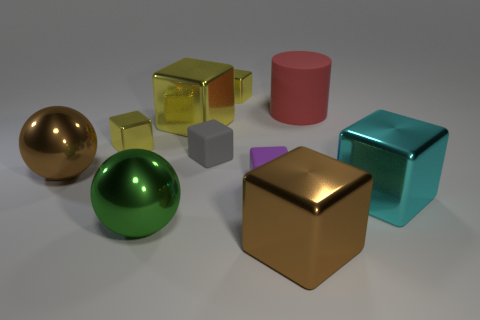How many cylinders are yellow metal things or small yellow objects?
Your response must be concise. 0. Is there any other thing that is the same shape as the large matte object?
Keep it short and to the point. No. Is the number of big green things to the left of the gray block greater than the number of brown cubes that are right of the big cylinder?
Your answer should be compact. Yes. There is a object that is in front of the green shiny thing; how many brown metallic things are behind it?
Provide a short and direct response. 1. How many things are cyan objects or green rubber balls?
Provide a succinct answer. 1. Does the cyan object have the same shape as the large green metal object?
Give a very brief answer. No. What is the material of the green sphere?
Your answer should be compact. Metal. What number of big objects are both in front of the large green thing and on the left side of the tiny purple rubber thing?
Your response must be concise. 0. Is the size of the brown metal ball the same as the red cylinder?
Your answer should be compact. Yes. Does the metallic ball behind the cyan metallic thing have the same size as the purple rubber cube?
Ensure brevity in your answer.  No. 